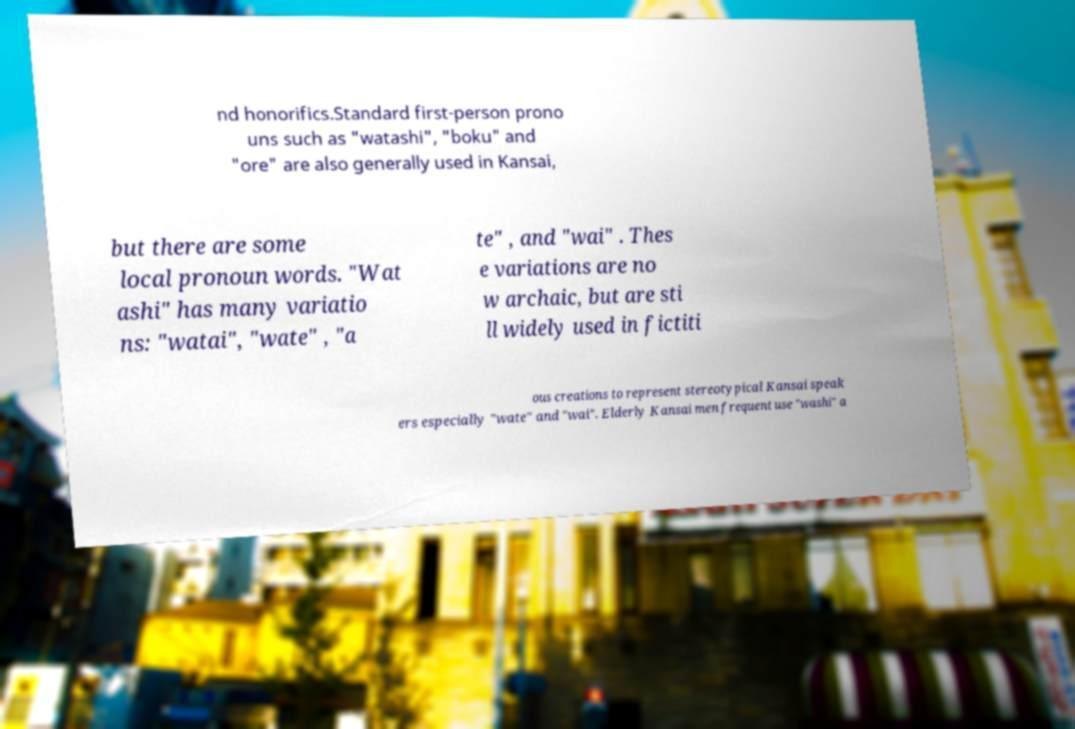I need the written content from this picture converted into text. Can you do that? nd honorifics.Standard first-person prono uns such as "watashi", "boku" and "ore" are also generally used in Kansai, but there are some local pronoun words. "Wat ashi" has many variatio ns: "watai", "wate" , "a te" , and "wai" . Thes e variations are no w archaic, but are sti ll widely used in fictiti ous creations to represent stereotypical Kansai speak ers especially "wate" and "wai". Elderly Kansai men frequent use "washi" a 